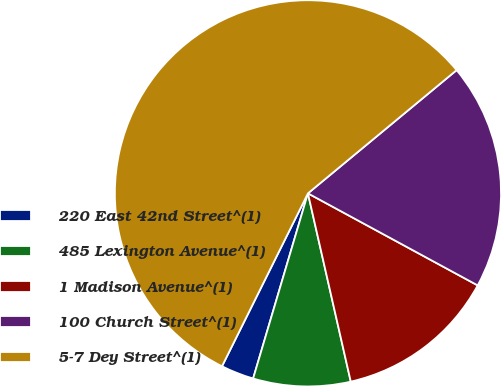Convert chart to OTSL. <chart><loc_0><loc_0><loc_500><loc_500><pie_chart><fcel>220 East 42nd Street^(1)<fcel>485 Lexington Avenue^(1)<fcel>1 Madison Avenue^(1)<fcel>100 Church Street^(1)<fcel>5-7 Dey Street^(1)<nl><fcel>2.76%<fcel>8.14%<fcel>13.53%<fcel>18.92%<fcel>56.64%<nl></chart> 